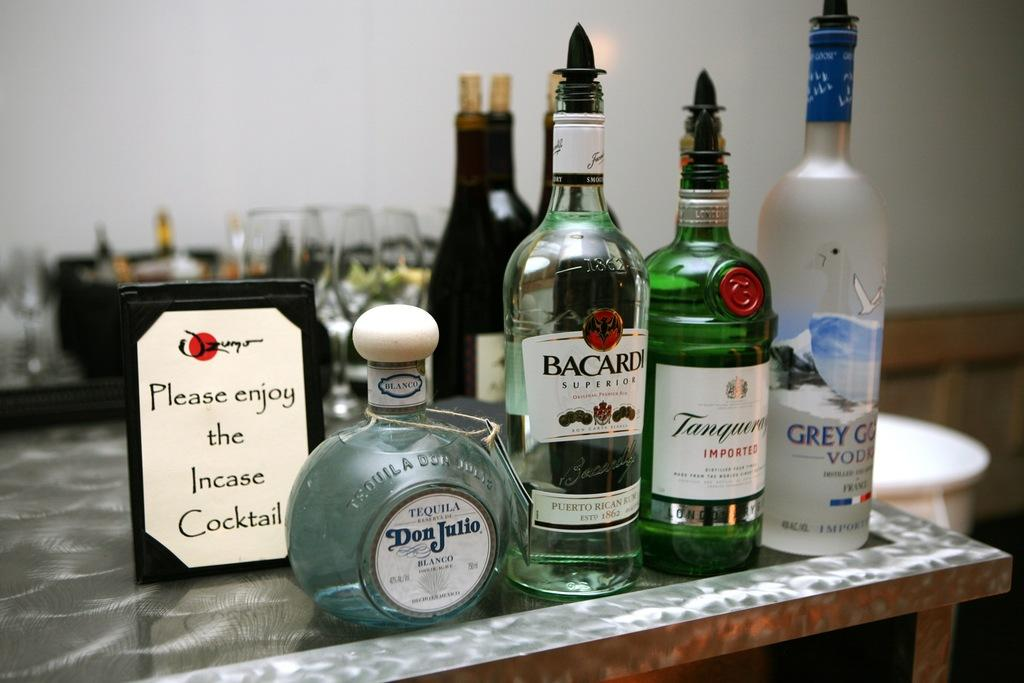<image>
Render a clear and concise summary of the photo. A bottle of Bacardi, Vodka, whisky and tequila sit on a table before a sign saying please enjoy. 